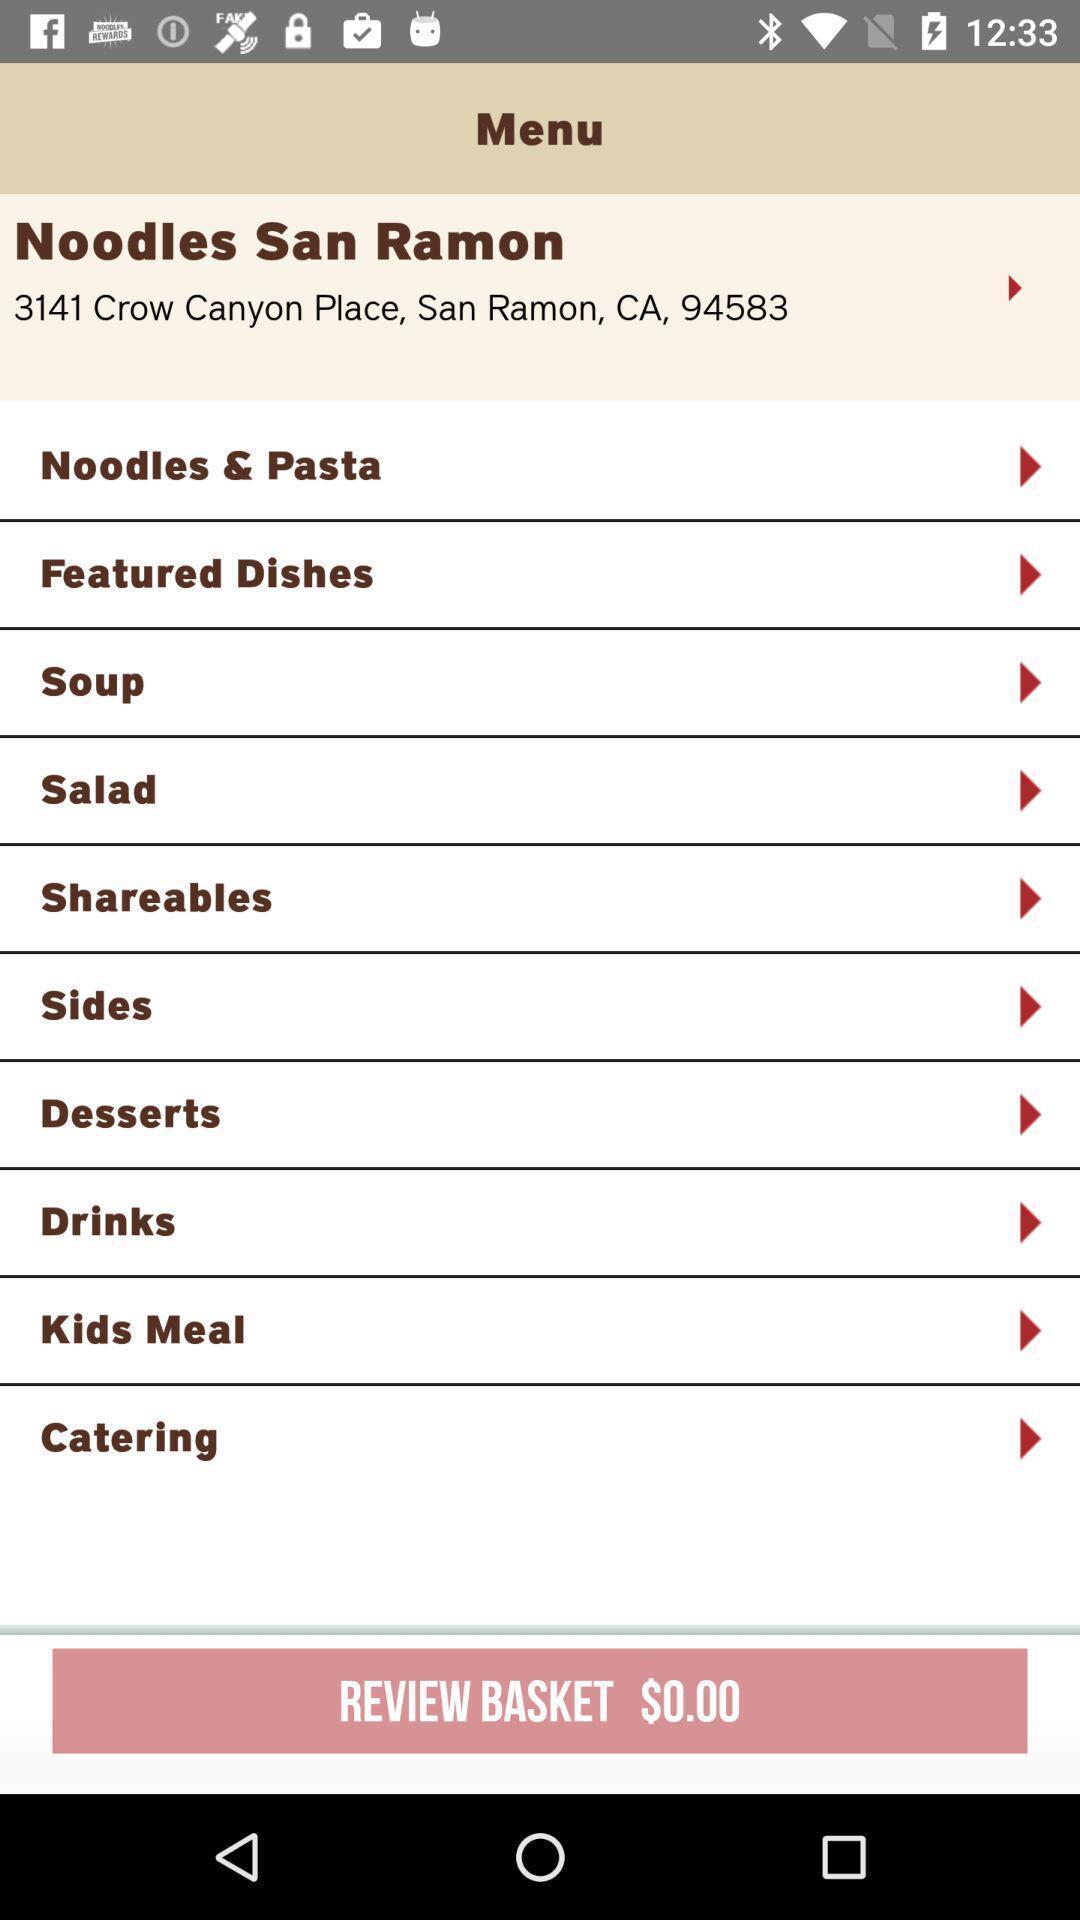Describe the visual elements of this screenshot. Page displaying the menu with different food items. 